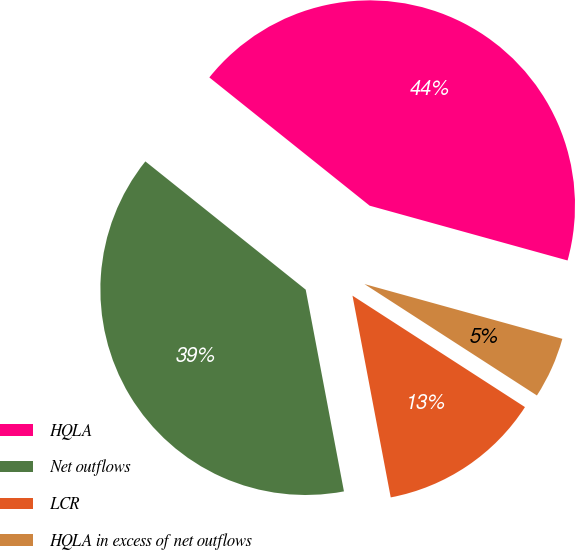Convert chart. <chart><loc_0><loc_0><loc_500><loc_500><pie_chart><fcel>HQLA<fcel>Net outflows<fcel>LCR<fcel>HQLA in excess of net outflows<nl><fcel>43.56%<fcel>38.72%<fcel>12.89%<fcel>4.83%<nl></chart> 